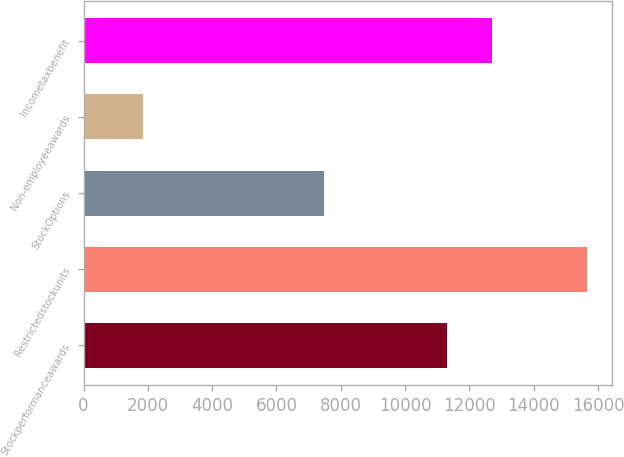Convert chart. <chart><loc_0><loc_0><loc_500><loc_500><bar_chart><fcel>Stockperformanceawards<fcel>Restrictedstockunits<fcel>StockOptions<fcel>Non-employeeawards<fcel>Incometaxbenefit<nl><fcel>11315<fcel>15643<fcel>7473<fcel>1834<fcel>12695.9<nl></chart> 